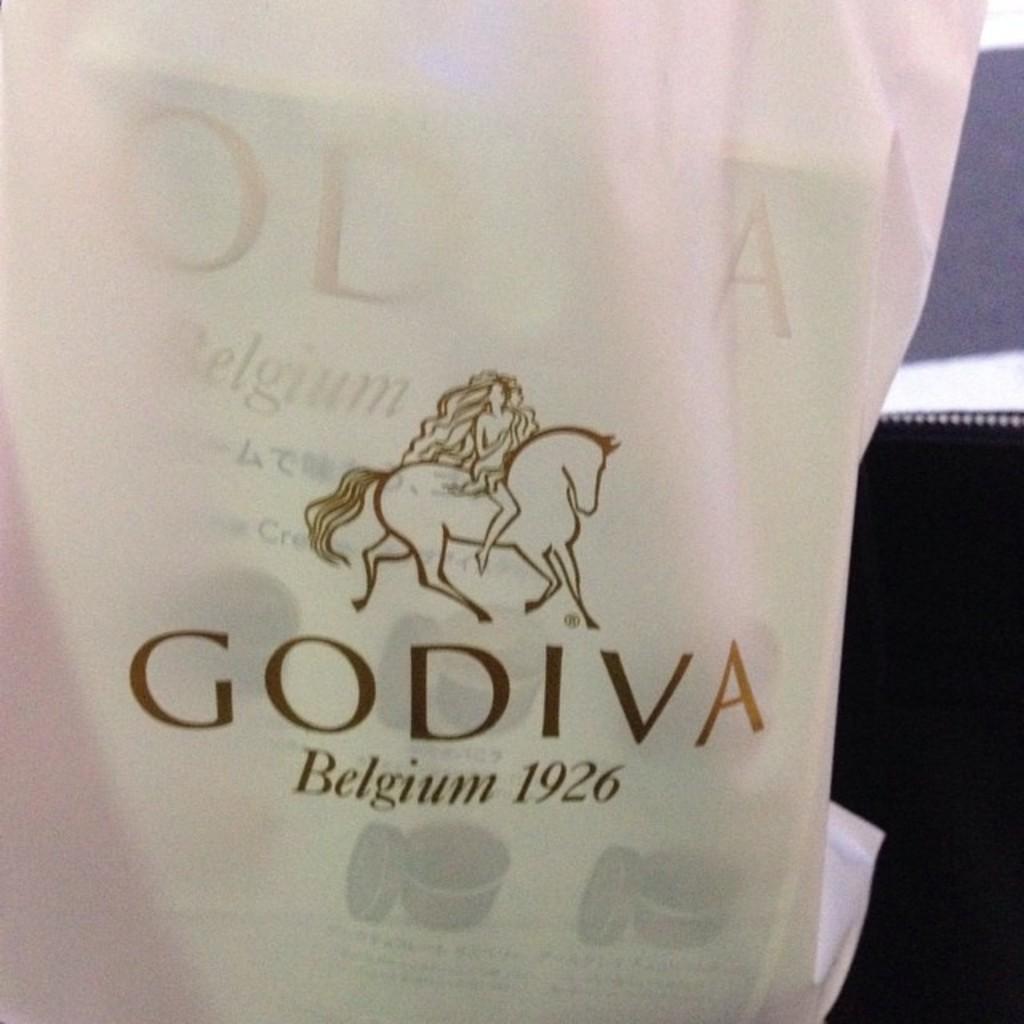What year was the godiva company established?
Provide a short and direct response. 1926. What country is godiva from?
Your answer should be compact. Belgium. 